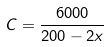<formula> <loc_0><loc_0><loc_500><loc_500>C = \frac { 6 0 0 0 } { 2 0 0 - 2 x }</formula> 